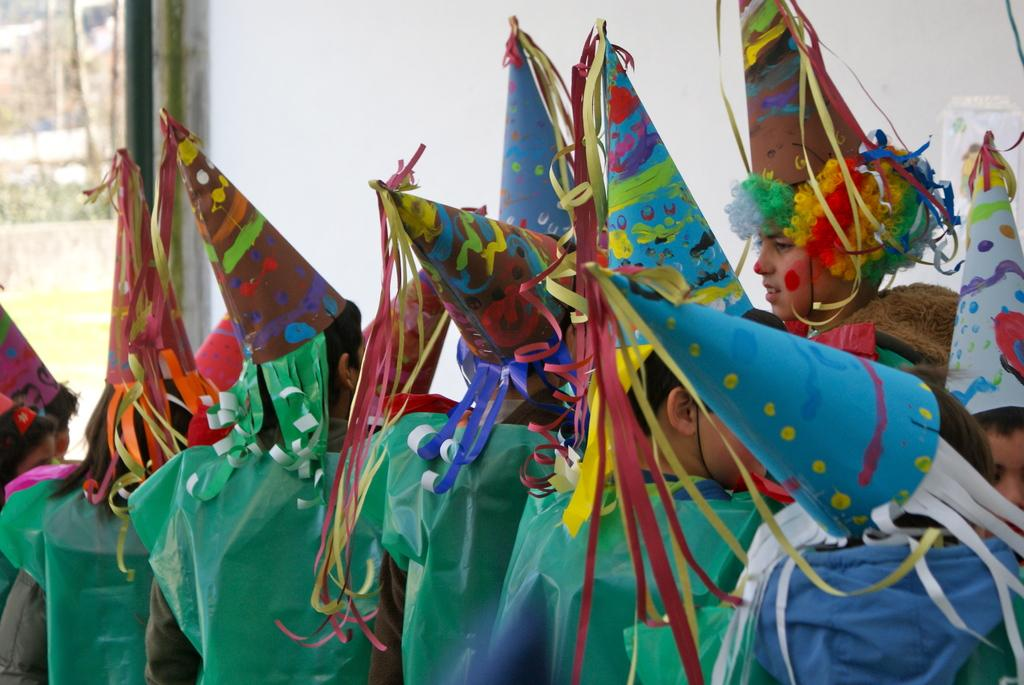What is happening in the image? There are people standing in the image, and they are watching something. What can be seen in the background of the image? There is a wall in the background of the image. What type of bone can be seen in the image? There is no bone present in the image. Can you see any squirrels in the image? There are no squirrels present in the image. 